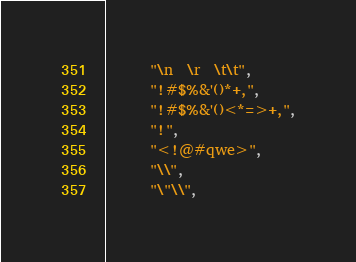<code> <loc_0><loc_0><loc_500><loc_500><_Scala_>      "\n  \r  \t\t",
      "!#$%&'()*+,",
      "!#$%&'()<*=>+,",
      "!",
      "<!@#qwe>",
      "\\",
      "\"\\",</code> 